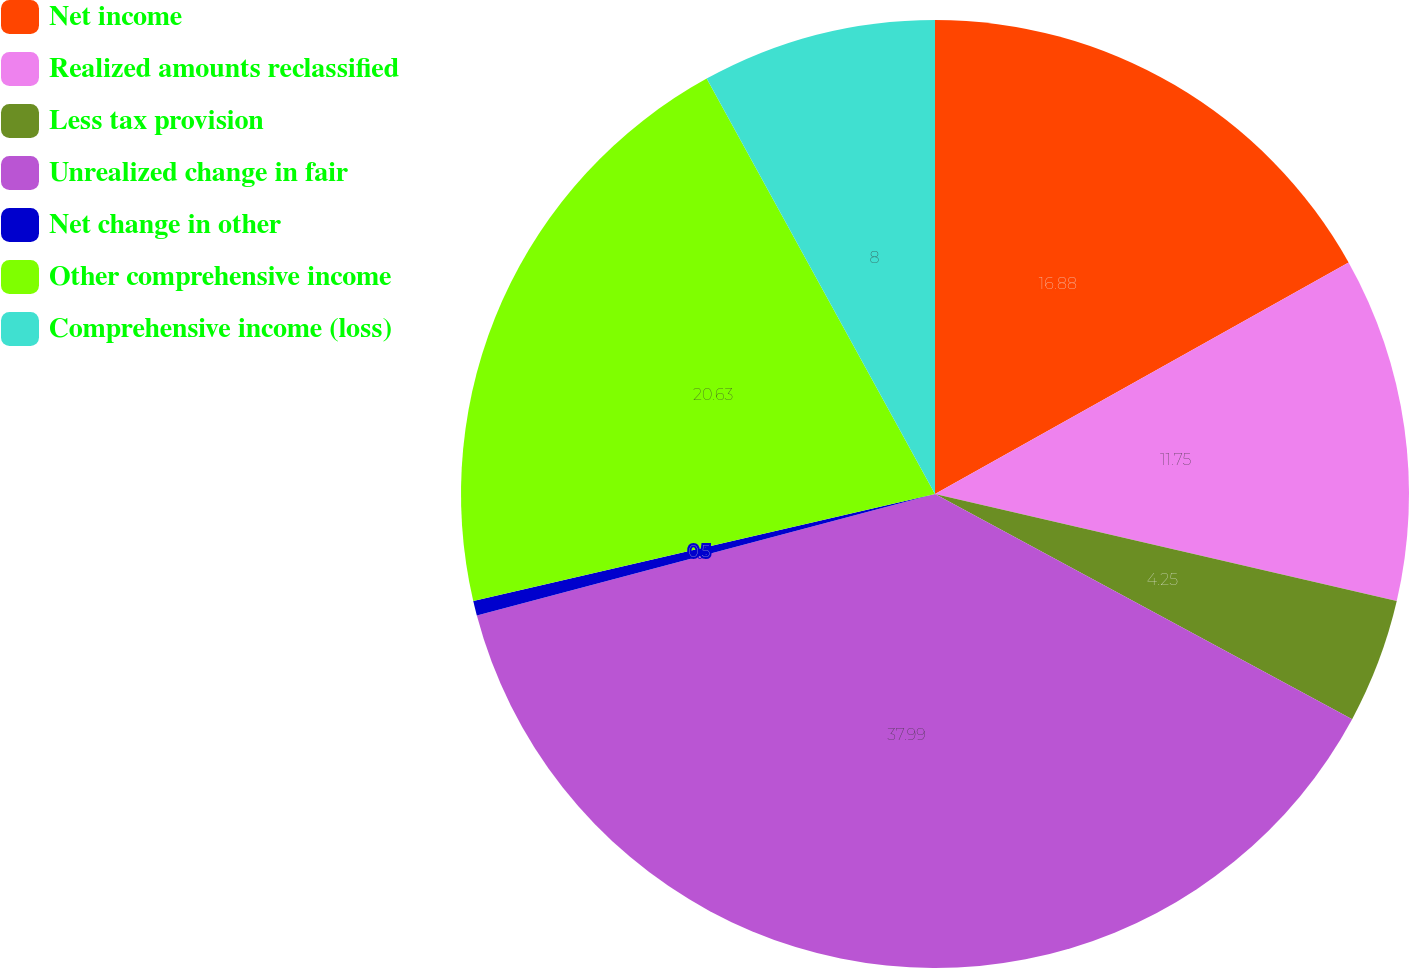<chart> <loc_0><loc_0><loc_500><loc_500><pie_chart><fcel>Net income<fcel>Realized amounts reclassified<fcel>Less tax provision<fcel>Unrealized change in fair<fcel>Net change in other<fcel>Other comprehensive income<fcel>Comprehensive income (loss)<nl><fcel>16.88%<fcel>11.75%<fcel>4.25%<fcel>38.0%<fcel>0.5%<fcel>20.63%<fcel>8.0%<nl></chart> 